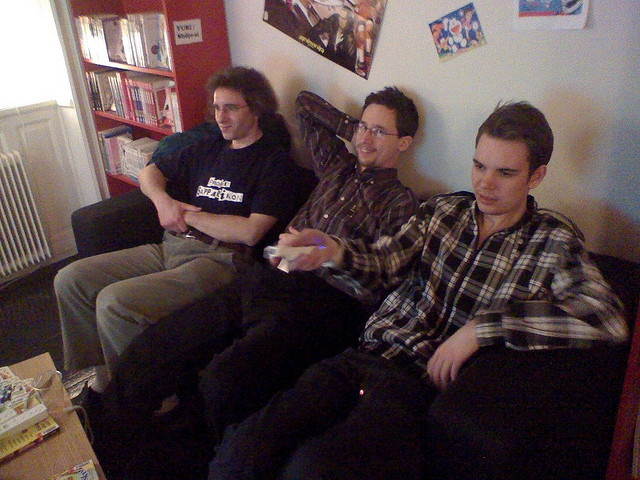Describe the objects in this image and their specific colors. I can see people in white, black, gray, and maroon tones, people in white, black, maroon, and brown tones, people in white, black, gray, and maroon tones, couch in white, black, navy, and purple tones, and book in white, darkgray, gray, and tan tones in this image. 